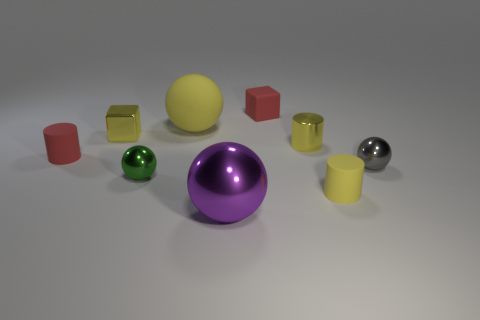How many cubes are purple objects or red matte objects?
Make the answer very short. 1. What number of large cyan cylinders are there?
Give a very brief answer. 0. What is the size of the rubber cylinder on the right side of the red object on the right side of the green thing?
Offer a terse response. Small. What number of other objects are the same size as the shiny block?
Keep it short and to the point. 6. There is a large purple sphere; how many big yellow matte balls are behind it?
Ensure brevity in your answer.  1. The purple metal thing is what size?
Your answer should be compact. Large. Is the material of the block to the left of the big purple shiny sphere the same as the block behind the matte sphere?
Your answer should be compact. No. Is there another shiny sphere of the same color as the big metal sphere?
Offer a terse response. No. What color is the thing that is the same size as the purple ball?
Provide a succinct answer. Yellow. Does the large ball that is behind the small yellow matte cylinder have the same color as the metallic cube?
Make the answer very short. Yes. 